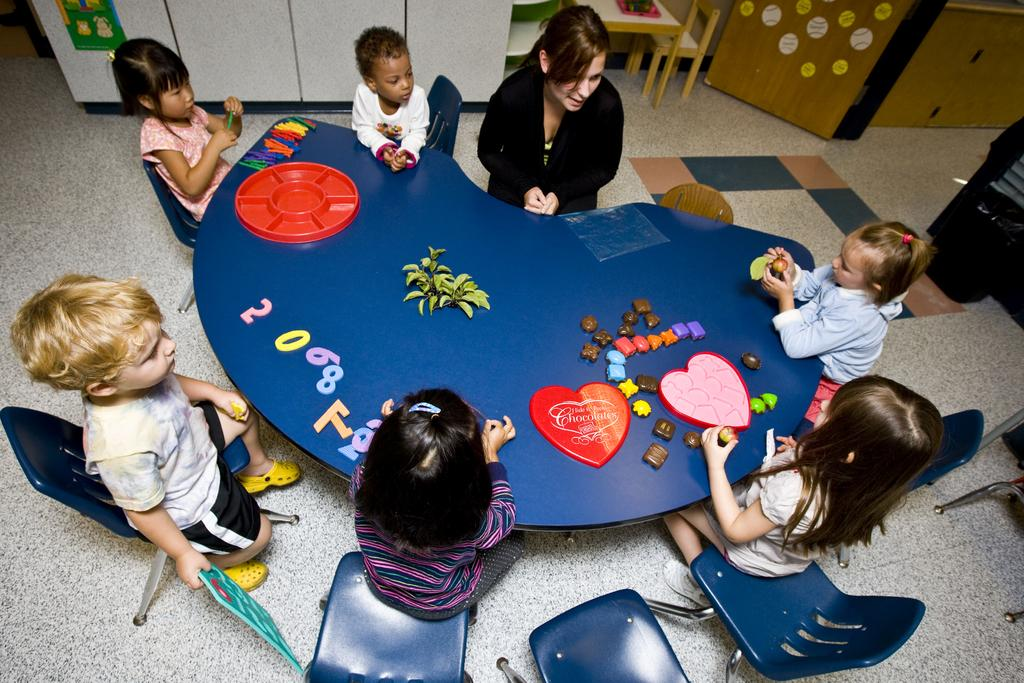How many people are in the image? There is a group of people in the image. What are the people doing in the image? The people are sitting around a table. What items can be seen on the table? There are toys and plants on the table. Can you describe the setting at the back of the image? There is a table and a chair at the back of the image. What type of oil is being discussed by the people in the image? There is no mention of oil in the image; the people are sitting around a table with toys and plants. 